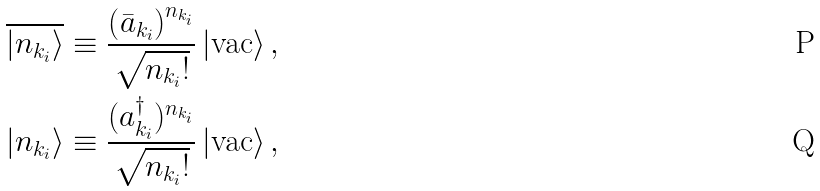Convert formula to latex. <formula><loc_0><loc_0><loc_500><loc_500>\overline { \left | n _ { k _ { i } } \right \rangle } \equiv \frac { \left ( \bar { a } _ { k _ { i } } \right ) ^ { n _ { k _ { i } } } } { \sqrt { n _ { k _ { i } } ! } } \left | \text {vac} \right \rangle , \\ \left | n _ { k _ { i } } \right \rangle \equiv \frac { ( a _ { k _ { i } } ^ { \dag } ) ^ { n _ { k _ { i } } } } { \sqrt { n _ { k _ { i } } ! } } \left | \text {vac} \right \rangle ,</formula> 